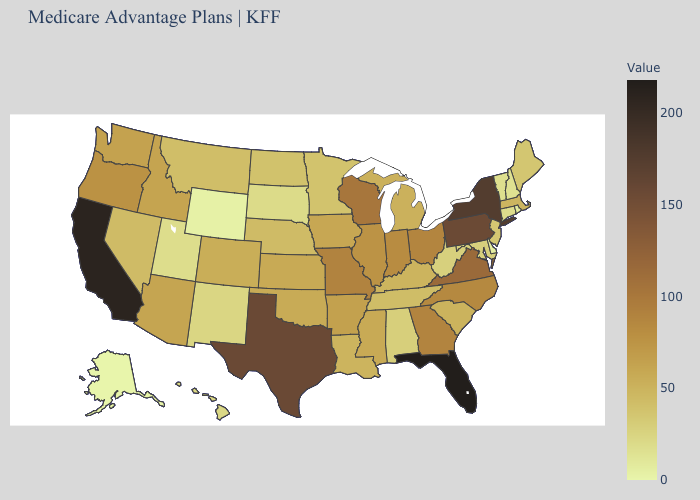Does the map have missing data?
Keep it brief. No. Among the states that border Mississippi , which have the lowest value?
Quick response, please. Alabama. Among the states that border South Carolina , does North Carolina have the highest value?
Be succinct. No. Which states have the highest value in the USA?
Write a very short answer. Florida. 